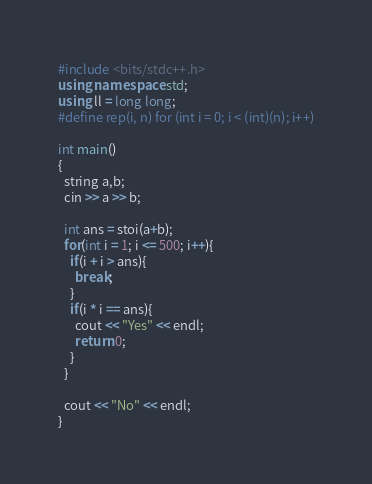<code> <loc_0><loc_0><loc_500><loc_500><_C++_>#include <bits/stdc++.h>
using namespace std;
using ll = long long;
#define rep(i, n) for (int i = 0; i < (int)(n); i++)

int main()
{
  string a,b;
  cin >> a >> b;
  
  int ans = stoi(a+b);
  for(int i = 1; i <= 500; i++){
    if(i + i > ans){
      break;
    }
    if(i * i == ans){
      cout << "Yes" << endl;
      return 0;
    }
  }
  
  cout << "No" << endl;
}</code> 